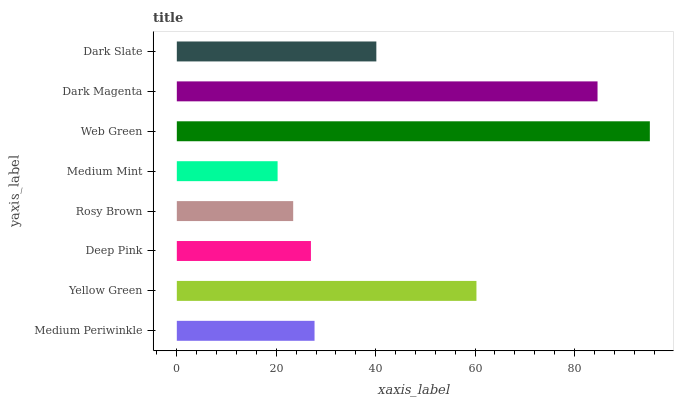Is Medium Mint the minimum?
Answer yes or no. Yes. Is Web Green the maximum?
Answer yes or no. Yes. Is Yellow Green the minimum?
Answer yes or no. No. Is Yellow Green the maximum?
Answer yes or no. No. Is Yellow Green greater than Medium Periwinkle?
Answer yes or no. Yes. Is Medium Periwinkle less than Yellow Green?
Answer yes or no. Yes. Is Medium Periwinkle greater than Yellow Green?
Answer yes or no. No. Is Yellow Green less than Medium Periwinkle?
Answer yes or no. No. Is Dark Slate the high median?
Answer yes or no. Yes. Is Medium Periwinkle the low median?
Answer yes or no. Yes. Is Yellow Green the high median?
Answer yes or no. No. Is Deep Pink the low median?
Answer yes or no. No. 